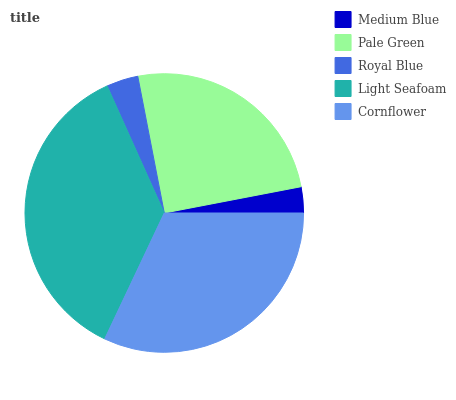Is Medium Blue the minimum?
Answer yes or no. Yes. Is Light Seafoam the maximum?
Answer yes or no. Yes. Is Pale Green the minimum?
Answer yes or no. No. Is Pale Green the maximum?
Answer yes or no. No. Is Pale Green greater than Medium Blue?
Answer yes or no. Yes. Is Medium Blue less than Pale Green?
Answer yes or no. Yes. Is Medium Blue greater than Pale Green?
Answer yes or no. No. Is Pale Green less than Medium Blue?
Answer yes or no. No. Is Pale Green the high median?
Answer yes or no. Yes. Is Pale Green the low median?
Answer yes or no. Yes. Is Cornflower the high median?
Answer yes or no. No. Is Royal Blue the low median?
Answer yes or no. No. 